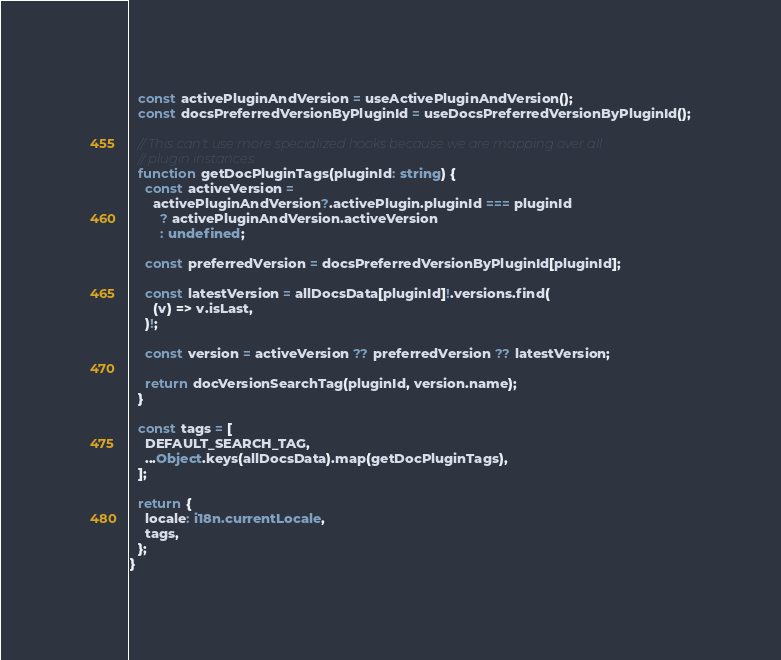Convert code to text. <code><loc_0><loc_0><loc_500><loc_500><_TypeScript_>  const activePluginAndVersion = useActivePluginAndVersion();
  const docsPreferredVersionByPluginId = useDocsPreferredVersionByPluginId();

  // This can't use more specialized hooks because we are mapping over all
  // plugin instances.
  function getDocPluginTags(pluginId: string) {
    const activeVersion =
      activePluginAndVersion?.activePlugin.pluginId === pluginId
        ? activePluginAndVersion.activeVersion
        : undefined;

    const preferredVersion = docsPreferredVersionByPluginId[pluginId];

    const latestVersion = allDocsData[pluginId]!.versions.find(
      (v) => v.isLast,
    )!;

    const version = activeVersion ?? preferredVersion ?? latestVersion;

    return docVersionSearchTag(pluginId, version.name);
  }

  const tags = [
    DEFAULT_SEARCH_TAG,
    ...Object.keys(allDocsData).map(getDocPluginTags),
  ];

  return {
    locale: i18n.currentLocale,
    tags,
  };
}
</code> 